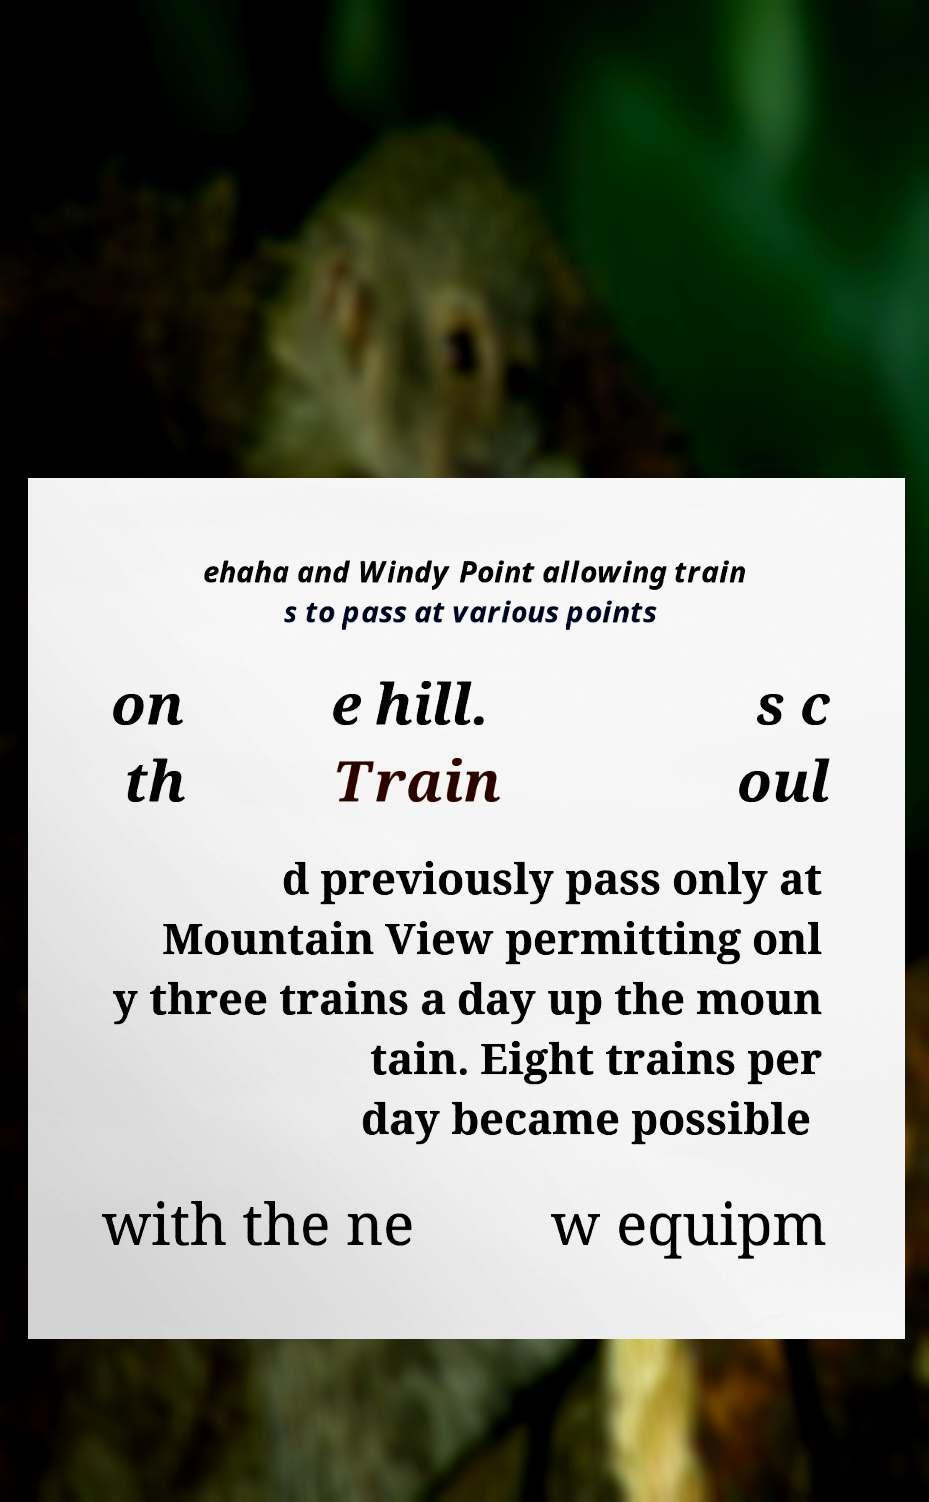There's text embedded in this image that I need extracted. Can you transcribe it verbatim? ehaha and Windy Point allowing train s to pass at various points on th e hill. Train s c oul d previously pass only at Mountain View permitting onl y three trains a day up the moun tain. Eight trains per day became possible with the ne w equipm 